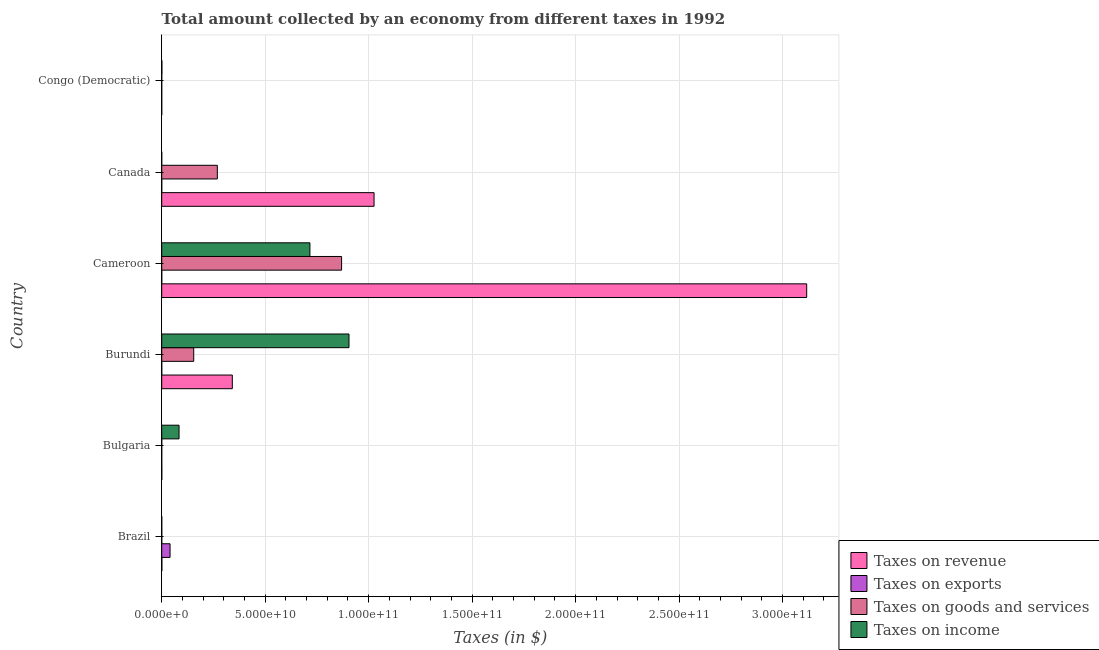Are the number of bars per tick equal to the number of legend labels?
Your answer should be very brief. Yes. Are the number of bars on each tick of the Y-axis equal?
Keep it short and to the point. Yes. How many bars are there on the 3rd tick from the bottom?
Keep it short and to the point. 4. What is the label of the 3rd group of bars from the top?
Your answer should be compact. Cameroon. In how many cases, is the number of bars for a given country not equal to the number of legend labels?
Make the answer very short. 0. What is the amount collected as tax on income in Congo (Democratic)?
Offer a very short reply. 8.40e+07. Across all countries, what is the maximum amount collected as tax on exports?
Ensure brevity in your answer.  4.03e+09. Across all countries, what is the minimum amount collected as tax on exports?
Give a very brief answer. 34.5. In which country was the amount collected as tax on goods maximum?
Offer a terse response. Cameroon. In which country was the amount collected as tax on exports minimum?
Your answer should be very brief. Bulgaria. What is the total amount collected as tax on income in the graph?
Your response must be concise. 1.71e+11. What is the difference between the amount collected as tax on revenue in Brazil and that in Congo (Democratic)?
Offer a very short reply. 6.24e+07. What is the difference between the amount collected as tax on goods in Burundi and the amount collected as tax on revenue in Brazil?
Your answer should be very brief. 1.54e+1. What is the average amount collected as tax on revenue per country?
Your response must be concise. 7.47e+1. What is the difference between the amount collected as tax on revenue and amount collected as tax on goods in Canada?
Make the answer very short. 7.57e+1. What is the difference between the highest and the second highest amount collected as tax on goods?
Provide a short and direct response. 6.00e+1. What is the difference between the highest and the lowest amount collected as tax on goods?
Provide a succinct answer. 8.69e+1. Is the sum of the amount collected as tax on revenue in Bulgaria and Congo (Democratic) greater than the maximum amount collected as tax on income across all countries?
Provide a succinct answer. No. What does the 2nd bar from the top in Canada represents?
Keep it short and to the point. Taxes on goods and services. What does the 2nd bar from the bottom in Congo (Democratic) represents?
Provide a short and direct response. Taxes on exports. How many bars are there?
Provide a short and direct response. 24. Are all the bars in the graph horizontal?
Ensure brevity in your answer.  Yes. What is the difference between two consecutive major ticks on the X-axis?
Provide a short and direct response. 5.00e+1. Are the values on the major ticks of X-axis written in scientific E-notation?
Make the answer very short. Yes. Does the graph contain grids?
Give a very brief answer. Yes. How many legend labels are there?
Provide a succinct answer. 4. How are the legend labels stacked?
Ensure brevity in your answer.  Vertical. What is the title of the graph?
Offer a very short reply. Total amount collected by an economy from different taxes in 1992. What is the label or title of the X-axis?
Keep it short and to the point. Taxes (in $). What is the Taxes (in $) in Taxes on revenue in Brazil?
Your answer should be very brief. 6.24e+07. What is the Taxes (in $) in Taxes on exports in Brazil?
Your answer should be compact. 4.03e+09. What is the Taxes (in $) of Taxes on goods and services in Brazil?
Give a very brief answer. 2.66e+07. What is the Taxes (in $) in Taxes on income in Brazil?
Your answer should be compact. 1.51e+07. What is the Taxes (in $) in Taxes on revenue in Bulgaria?
Provide a short and direct response. 3.39e+07. What is the Taxes (in $) of Taxes on exports in Bulgaria?
Your answer should be compact. 34.5. What is the Taxes (in $) in Taxes on goods and services in Bulgaria?
Ensure brevity in your answer.  1.02e+07. What is the Taxes (in $) in Taxes on income in Bulgaria?
Make the answer very short. 8.37e+09. What is the Taxes (in $) in Taxes on revenue in Burundi?
Provide a succinct answer. 3.41e+1. What is the Taxes (in $) of Taxes on goods and services in Burundi?
Provide a succinct answer. 1.55e+1. What is the Taxes (in $) in Taxes on income in Burundi?
Give a very brief answer. 9.05e+1. What is the Taxes (in $) of Taxes on revenue in Cameroon?
Keep it short and to the point. 3.12e+11. What is the Taxes (in $) of Taxes on exports in Cameroon?
Keep it short and to the point. 1.52e+07. What is the Taxes (in $) of Taxes on goods and services in Cameroon?
Provide a succinct answer. 8.69e+1. What is the Taxes (in $) of Taxes on income in Cameroon?
Make the answer very short. 7.16e+1. What is the Taxes (in $) in Taxes on revenue in Canada?
Offer a terse response. 1.03e+11. What is the Taxes (in $) of Taxes on exports in Canada?
Provide a succinct answer. 1.18e+07. What is the Taxes (in $) in Taxes on goods and services in Canada?
Make the answer very short. 2.69e+1. What is the Taxes (in $) in Taxes on income in Canada?
Your response must be concise. 104.33. What is the Taxes (in $) in Taxes on revenue in Congo (Democratic)?
Your answer should be very brief. 482.66. What is the Taxes (in $) in Taxes on exports in Congo (Democratic)?
Give a very brief answer. 3.20e+05. What is the Taxes (in $) in Taxes on goods and services in Congo (Democratic)?
Your answer should be compact. 188.26. What is the Taxes (in $) in Taxes on income in Congo (Democratic)?
Provide a short and direct response. 8.40e+07. Across all countries, what is the maximum Taxes (in $) in Taxes on revenue?
Offer a terse response. 3.12e+11. Across all countries, what is the maximum Taxes (in $) of Taxes on exports?
Provide a succinct answer. 4.03e+09. Across all countries, what is the maximum Taxes (in $) of Taxes on goods and services?
Give a very brief answer. 8.69e+1. Across all countries, what is the maximum Taxes (in $) of Taxes on income?
Provide a short and direct response. 9.05e+1. Across all countries, what is the minimum Taxes (in $) in Taxes on revenue?
Your answer should be very brief. 482.66. Across all countries, what is the minimum Taxes (in $) in Taxes on exports?
Offer a terse response. 34.5. Across all countries, what is the minimum Taxes (in $) of Taxes on goods and services?
Provide a short and direct response. 188.26. Across all countries, what is the minimum Taxes (in $) of Taxes on income?
Provide a succinct answer. 104.33. What is the total Taxes (in $) in Taxes on revenue in the graph?
Your response must be concise. 4.48e+11. What is the total Taxes (in $) of Taxes on exports in the graph?
Provide a succinct answer. 4.07e+09. What is the total Taxes (in $) in Taxes on goods and services in the graph?
Make the answer very short. 1.29e+11. What is the total Taxes (in $) of Taxes on income in the graph?
Ensure brevity in your answer.  1.71e+11. What is the difference between the Taxes (in $) of Taxes on revenue in Brazil and that in Bulgaria?
Your response must be concise. 2.84e+07. What is the difference between the Taxes (in $) of Taxes on exports in Brazil and that in Bulgaria?
Your response must be concise. 4.03e+09. What is the difference between the Taxes (in $) in Taxes on goods and services in Brazil and that in Bulgaria?
Make the answer very short. 1.63e+07. What is the difference between the Taxes (in $) of Taxes on income in Brazil and that in Bulgaria?
Keep it short and to the point. -8.36e+09. What is the difference between the Taxes (in $) in Taxes on revenue in Brazil and that in Burundi?
Make the answer very short. -3.41e+1. What is the difference between the Taxes (in $) in Taxes on exports in Brazil and that in Burundi?
Keep it short and to the point. 4.02e+09. What is the difference between the Taxes (in $) of Taxes on goods and services in Brazil and that in Burundi?
Ensure brevity in your answer.  -1.54e+1. What is the difference between the Taxes (in $) of Taxes on income in Brazil and that in Burundi?
Your answer should be very brief. -9.05e+1. What is the difference between the Taxes (in $) in Taxes on revenue in Brazil and that in Cameroon?
Your answer should be very brief. -3.12e+11. What is the difference between the Taxes (in $) in Taxes on exports in Brazil and that in Cameroon?
Provide a succinct answer. 4.01e+09. What is the difference between the Taxes (in $) of Taxes on goods and services in Brazil and that in Cameroon?
Ensure brevity in your answer.  -8.69e+1. What is the difference between the Taxes (in $) of Taxes on income in Brazil and that in Cameroon?
Your answer should be compact. -7.16e+1. What is the difference between the Taxes (in $) in Taxes on revenue in Brazil and that in Canada?
Give a very brief answer. -1.03e+11. What is the difference between the Taxes (in $) of Taxes on exports in Brazil and that in Canada?
Your response must be concise. 4.02e+09. What is the difference between the Taxes (in $) of Taxes on goods and services in Brazil and that in Canada?
Your response must be concise. -2.68e+1. What is the difference between the Taxes (in $) of Taxes on income in Brazil and that in Canada?
Give a very brief answer. 1.51e+07. What is the difference between the Taxes (in $) of Taxes on revenue in Brazil and that in Congo (Democratic)?
Provide a succinct answer. 6.24e+07. What is the difference between the Taxes (in $) of Taxes on exports in Brazil and that in Congo (Democratic)?
Provide a succinct answer. 4.03e+09. What is the difference between the Taxes (in $) in Taxes on goods and services in Brazil and that in Congo (Democratic)?
Give a very brief answer. 2.66e+07. What is the difference between the Taxes (in $) in Taxes on income in Brazil and that in Congo (Democratic)?
Make the answer very short. -6.89e+07. What is the difference between the Taxes (in $) in Taxes on revenue in Bulgaria and that in Burundi?
Make the answer very short. -3.41e+1. What is the difference between the Taxes (in $) of Taxes on exports in Bulgaria and that in Burundi?
Provide a succinct answer. -1.20e+07. What is the difference between the Taxes (in $) of Taxes on goods and services in Bulgaria and that in Burundi?
Provide a short and direct response. -1.55e+1. What is the difference between the Taxes (in $) of Taxes on income in Bulgaria and that in Burundi?
Provide a short and direct response. -8.21e+1. What is the difference between the Taxes (in $) of Taxes on revenue in Bulgaria and that in Cameroon?
Offer a very short reply. -3.12e+11. What is the difference between the Taxes (in $) of Taxes on exports in Bulgaria and that in Cameroon?
Ensure brevity in your answer.  -1.52e+07. What is the difference between the Taxes (in $) in Taxes on goods and services in Bulgaria and that in Cameroon?
Provide a succinct answer. -8.69e+1. What is the difference between the Taxes (in $) in Taxes on income in Bulgaria and that in Cameroon?
Ensure brevity in your answer.  -6.32e+1. What is the difference between the Taxes (in $) of Taxes on revenue in Bulgaria and that in Canada?
Offer a very short reply. -1.03e+11. What is the difference between the Taxes (in $) in Taxes on exports in Bulgaria and that in Canada?
Offer a terse response. -1.18e+07. What is the difference between the Taxes (in $) of Taxes on goods and services in Bulgaria and that in Canada?
Give a very brief answer. -2.69e+1. What is the difference between the Taxes (in $) of Taxes on income in Bulgaria and that in Canada?
Provide a short and direct response. 8.37e+09. What is the difference between the Taxes (in $) in Taxes on revenue in Bulgaria and that in Congo (Democratic)?
Offer a very short reply. 3.39e+07. What is the difference between the Taxes (in $) of Taxes on exports in Bulgaria and that in Congo (Democratic)?
Your answer should be compact. -3.20e+05. What is the difference between the Taxes (in $) in Taxes on goods and services in Bulgaria and that in Congo (Democratic)?
Your answer should be very brief. 1.02e+07. What is the difference between the Taxes (in $) of Taxes on income in Bulgaria and that in Congo (Democratic)?
Make the answer very short. 8.29e+09. What is the difference between the Taxes (in $) of Taxes on revenue in Burundi and that in Cameroon?
Offer a very short reply. -2.78e+11. What is the difference between the Taxes (in $) in Taxes on exports in Burundi and that in Cameroon?
Your response must be concise. -3.20e+06. What is the difference between the Taxes (in $) in Taxes on goods and services in Burundi and that in Cameroon?
Keep it short and to the point. -7.15e+1. What is the difference between the Taxes (in $) in Taxes on income in Burundi and that in Cameroon?
Provide a short and direct response. 1.89e+1. What is the difference between the Taxes (in $) of Taxes on revenue in Burundi and that in Canada?
Make the answer very short. -6.85e+1. What is the difference between the Taxes (in $) of Taxes on exports in Burundi and that in Canada?
Your answer should be very brief. 1.70e+05. What is the difference between the Taxes (in $) of Taxes on goods and services in Burundi and that in Canada?
Offer a very short reply. -1.14e+1. What is the difference between the Taxes (in $) of Taxes on income in Burundi and that in Canada?
Provide a short and direct response. 9.05e+1. What is the difference between the Taxes (in $) in Taxes on revenue in Burundi and that in Congo (Democratic)?
Offer a terse response. 3.41e+1. What is the difference between the Taxes (in $) of Taxes on exports in Burundi and that in Congo (Democratic)?
Your answer should be compact. 1.17e+07. What is the difference between the Taxes (in $) in Taxes on goods and services in Burundi and that in Congo (Democratic)?
Ensure brevity in your answer.  1.55e+1. What is the difference between the Taxes (in $) in Taxes on income in Burundi and that in Congo (Democratic)?
Your response must be concise. 9.04e+1. What is the difference between the Taxes (in $) in Taxes on revenue in Cameroon and that in Canada?
Your response must be concise. 2.09e+11. What is the difference between the Taxes (in $) of Taxes on exports in Cameroon and that in Canada?
Provide a short and direct response. 3.37e+06. What is the difference between the Taxes (in $) of Taxes on goods and services in Cameroon and that in Canada?
Offer a very short reply. 6.00e+1. What is the difference between the Taxes (in $) in Taxes on income in Cameroon and that in Canada?
Your response must be concise. 7.16e+1. What is the difference between the Taxes (in $) in Taxes on revenue in Cameroon and that in Congo (Democratic)?
Make the answer very short. 3.12e+11. What is the difference between the Taxes (in $) in Taxes on exports in Cameroon and that in Congo (Democratic)?
Provide a short and direct response. 1.49e+07. What is the difference between the Taxes (in $) of Taxes on goods and services in Cameroon and that in Congo (Democratic)?
Offer a terse response. 8.69e+1. What is the difference between the Taxes (in $) in Taxes on income in Cameroon and that in Congo (Democratic)?
Make the answer very short. 7.15e+1. What is the difference between the Taxes (in $) in Taxes on revenue in Canada and that in Congo (Democratic)?
Your answer should be very brief. 1.03e+11. What is the difference between the Taxes (in $) in Taxes on exports in Canada and that in Congo (Democratic)?
Ensure brevity in your answer.  1.15e+07. What is the difference between the Taxes (in $) in Taxes on goods and services in Canada and that in Congo (Democratic)?
Provide a succinct answer. 2.69e+1. What is the difference between the Taxes (in $) in Taxes on income in Canada and that in Congo (Democratic)?
Your answer should be compact. -8.40e+07. What is the difference between the Taxes (in $) of Taxes on revenue in Brazil and the Taxes (in $) of Taxes on exports in Bulgaria?
Offer a very short reply. 6.24e+07. What is the difference between the Taxes (in $) in Taxes on revenue in Brazil and the Taxes (in $) in Taxes on goods and services in Bulgaria?
Offer a very short reply. 5.21e+07. What is the difference between the Taxes (in $) in Taxes on revenue in Brazil and the Taxes (in $) in Taxes on income in Bulgaria?
Offer a very short reply. -8.31e+09. What is the difference between the Taxes (in $) in Taxes on exports in Brazil and the Taxes (in $) in Taxes on goods and services in Bulgaria?
Provide a succinct answer. 4.02e+09. What is the difference between the Taxes (in $) in Taxes on exports in Brazil and the Taxes (in $) in Taxes on income in Bulgaria?
Give a very brief answer. -4.34e+09. What is the difference between the Taxes (in $) in Taxes on goods and services in Brazil and the Taxes (in $) in Taxes on income in Bulgaria?
Offer a terse response. -8.35e+09. What is the difference between the Taxes (in $) in Taxes on revenue in Brazil and the Taxes (in $) in Taxes on exports in Burundi?
Your response must be concise. 5.04e+07. What is the difference between the Taxes (in $) of Taxes on revenue in Brazil and the Taxes (in $) of Taxes on goods and services in Burundi?
Ensure brevity in your answer.  -1.54e+1. What is the difference between the Taxes (in $) in Taxes on revenue in Brazil and the Taxes (in $) in Taxes on income in Burundi?
Keep it short and to the point. -9.04e+1. What is the difference between the Taxes (in $) of Taxes on exports in Brazil and the Taxes (in $) of Taxes on goods and services in Burundi?
Keep it short and to the point. -1.14e+1. What is the difference between the Taxes (in $) of Taxes on exports in Brazil and the Taxes (in $) of Taxes on income in Burundi?
Provide a short and direct response. -8.65e+1. What is the difference between the Taxes (in $) of Taxes on goods and services in Brazil and the Taxes (in $) of Taxes on income in Burundi?
Your response must be concise. -9.05e+1. What is the difference between the Taxes (in $) in Taxes on revenue in Brazil and the Taxes (in $) in Taxes on exports in Cameroon?
Ensure brevity in your answer.  4.72e+07. What is the difference between the Taxes (in $) in Taxes on revenue in Brazil and the Taxes (in $) in Taxes on goods and services in Cameroon?
Your answer should be compact. -8.69e+1. What is the difference between the Taxes (in $) of Taxes on revenue in Brazil and the Taxes (in $) of Taxes on income in Cameroon?
Provide a succinct answer. -7.16e+1. What is the difference between the Taxes (in $) in Taxes on exports in Brazil and the Taxes (in $) in Taxes on goods and services in Cameroon?
Provide a succinct answer. -8.29e+1. What is the difference between the Taxes (in $) in Taxes on exports in Brazil and the Taxes (in $) in Taxes on income in Cameroon?
Your answer should be compact. -6.76e+1. What is the difference between the Taxes (in $) in Taxes on goods and services in Brazil and the Taxes (in $) in Taxes on income in Cameroon?
Give a very brief answer. -7.16e+1. What is the difference between the Taxes (in $) in Taxes on revenue in Brazil and the Taxes (in $) in Taxes on exports in Canada?
Provide a short and direct response. 5.06e+07. What is the difference between the Taxes (in $) in Taxes on revenue in Brazil and the Taxes (in $) in Taxes on goods and services in Canada?
Give a very brief answer. -2.68e+1. What is the difference between the Taxes (in $) of Taxes on revenue in Brazil and the Taxes (in $) of Taxes on income in Canada?
Your response must be concise. 6.24e+07. What is the difference between the Taxes (in $) in Taxes on exports in Brazil and the Taxes (in $) in Taxes on goods and services in Canada?
Give a very brief answer. -2.28e+1. What is the difference between the Taxes (in $) of Taxes on exports in Brazil and the Taxes (in $) of Taxes on income in Canada?
Your answer should be very brief. 4.03e+09. What is the difference between the Taxes (in $) in Taxes on goods and services in Brazil and the Taxes (in $) in Taxes on income in Canada?
Offer a terse response. 2.66e+07. What is the difference between the Taxes (in $) in Taxes on revenue in Brazil and the Taxes (in $) in Taxes on exports in Congo (Democratic)?
Provide a short and direct response. 6.21e+07. What is the difference between the Taxes (in $) in Taxes on revenue in Brazil and the Taxes (in $) in Taxes on goods and services in Congo (Democratic)?
Provide a short and direct response. 6.24e+07. What is the difference between the Taxes (in $) of Taxes on revenue in Brazil and the Taxes (in $) of Taxes on income in Congo (Democratic)?
Offer a terse response. -2.16e+07. What is the difference between the Taxes (in $) in Taxes on exports in Brazil and the Taxes (in $) in Taxes on goods and services in Congo (Democratic)?
Your answer should be very brief. 4.03e+09. What is the difference between the Taxes (in $) of Taxes on exports in Brazil and the Taxes (in $) of Taxes on income in Congo (Democratic)?
Provide a short and direct response. 3.95e+09. What is the difference between the Taxes (in $) of Taxes on goods and services in Brazil and the Taxes (in $) of Taxes on income in Congo (Democratic)?
Your answer should be very brief. -5.74e+07. What is the difference between the Taxes (in $) in Taxes on revenue in Bulgaria and the Taxes (in $) in Taxes on exports in Burundi?
Keep it short and to the point. 2.19e+07. What is the difference between the Taxes (in $) in Taxes on revenue in Bulgaria and the Taxes (in $) in Taxes on goods and services in Burundi?
Keep it short and to the point. -1.54e+1. What is the difference between the Taxes (in $) in Taxes on revenue in Bulgaria and the Taxes (in $) in Taxes on income in Burundi?
Provide a succinct answer. -9.05e+1. What is the difference between the Taxes (in $) of Taxes on exports in Bulgaria and the Taxes (in $) of Taxes on goods and services in Burundi?
Provide a short and direct response. -1.55e+1. What is the difference between the Taxes (in $) of Taxes on exports in Bulgaria and the Taxes (in $) of Taxes on income in Burundi?
Your answer should be very brief. -9.05e+1. What is the difference between the Taxes (in $) of Taxes on goods and services in Bulgaria and the Taxes (in $) of Taxes on income in Burundi?
Provide a short and direct response. -9.05e+1. What is the difference between the Taxes (in $) in Taxes on revenue in Bulgaria and the Taxes (in $) in Taxes on exports in Cameroon?
Offer a terse response. 1.87e+07. What is the difference between the Taxes (in $) in Taxes on revenue in Bulgaria and the Taxes (in $) in Taxes on goods and services in Cameroon?
Provide a short and direct response. -8.69e+1. What is the difference between the Taxes (in $) in Taxes on revenue in Bulgaria and the Taxes (in $) in Taxes on income in Cameroon?
Offer a very short reply. -7.16e+1. What is the difference between the Taxes (in $) in Taxes on exports in Bulgaria and the Taxes (in $) in Taxes on goods and services in Cameroon?
Provide a succinct answer. -8.69e+1. What is the difference between the Taxes (in $) of Taxes on exports in Bulgaria and the Taxes (in $) of Taxes on income in Cameroon?
Provide a short and direct response. -7.16e+1. What is the difference between the Taxes (in $) in Taxes on goods and services in Bulgaria and the Taxes (in $) in Taxes on income in Cameroon?
Give a very brief answer. -7.16e+1. What is the difference between the Taxes (in $) of Taxes on revenue in Bulgaria and the Taxes (in $) of Taxes on exports in Canada?
Your response must be concise. 2.21e+07. What is the difference between the Taxes (in $) of Taxes on revenue in Bulgaria and the Taxes (in $) of Taxes on goods and services in Canada?
Provide a short and direct response. -2.68e+1. What is the difference between the Taxes (in $) in Taxes on revenue in Bulgaria and the Taxes (in $) in Taxes on income in Canada?
Provide a short and direct response. 3.39e+07. What is the difference between the Taxes (in $) in Taxes on exports in Bulgaria and the Taxes (in $) in Taxes on goods and services in Canada?
Make the answer very short. -2.69e+1. What is the difference between the Taxes (in $) in Taxes on exports in Bulgaria and the Taxes (in $) in Taxes on income in Canada?
Provide a succinct answer. -69.83. What is the difference between the Taxes (in $) in Taxes on goods and services in Bulgaria and the Taxes (in $) in Taxes on income in Canada?
Ensure brevity in your answer.  1.02e+07. What is the difference between the Taxes (in $) in Taxes on revenue in Bulgaria and the Taxes (in $) in Taxes on exports in Congo (Democratic)?
Keep it short and to the point. 3.36e+07. What is the difference between the Taxes (in $) in Taxes on revenue in Bulgaria and the Taxes (in $) in Taxes on goods and services in Congo (Democratic)?
Your response must be concise. 3.39e+07. What is the difference between the Taxes (in $) in Taxes on revenue in Bulgaria and the Taxes (in $) in Taxes on income in Congo (Democratic)?
Keep it short and to the point. -5.01e+07. What is the difference between the Taxes (in $) of Taxes on exports in Bulgaria and the Taxes (in $) of Taxes on goods and services in Congo (Democratic)?
Your answer should be compact. -153.76. What is the difference between the Taxes (in $) in Taxes on exports in Bulgaria and the Taxes (in $) in Taxes on income in Congo (Democratic)?
Keep it short and to the point. -8.40e+07. What is the difference between the Taxes (in $) of Taxes on goods and services in Bulgaria and the Taxes (in $) of Taxes on income in Congo (Democratic)?
Give a very brief answer. -7.38e+07. What is the difference between the Taxes (in $) in Taxes on revenue in Burundi and the Taxes (in $) in Taxes on exports in Cameroon?
Make the answer very short. 3.41e+1. What is the difference between the Taxes (in $) in Taxes on revenue in Burundi and the Taxes (in $) in Taxes on goods and services in Cameroon?
Keep it short and to the point. -5.28e+1. What is the difference between the Taxes (in $) in Taxes on revenue in Burundi and the Taxes (in $) in Taxes on income in Cameroon?
Make the answer very short. -3.75e+1. What is the difference between the Taxes (in $) of Taxes on exports in Burundi and the Taxes (in $) of Taxes on goods and services in Cameroon?
Offer a terse response. -8.69e+1. What is the difference between the Taxes (in $) of Taxes on exports in Burundi and the Taxes (in $) of Taxes on income in Cameroon?
Provide a succinct answer. -7.16e+1. What is the difference between the Taxes (in $) in Taxes on goods and services in Burundi and the Taxes (in $) in Taxes on income in Cameroon?
Ensure brevity in your answer.  -5.61e+1. What is the difference between the Taxes (in $) of Taxes on revenue in Burundi and the Taxes (in $) of Taxes on exports in Canada?
Give a very brief answer. 3.41e+1. What is the difference between the Taxes (in $) of Taxes on revenue in Burundi and the Taxes (in $) of Taxes on goods and services in Canada?
Ensure brevity in your answer.  7.24e+09. What is the difference between the Taxes (in $) in Taxes on revenue in Burundi and the Taxes (in $) in Taxes on income in Canada?
Offer a terse response. 3.41e+1. What is the difference between the Taxes (in $) of Taxes on exports in Burundi and the Taxes (in $) of Taxes on goods and services in Canada?
Offer a terse response. -2.69e+1. What is the difference between the Taxes (in $) of Taxes on exports in Burundi and the Taxes (in $) of Taxes on income in Canada?
Offer a terse response. 1.20e+07. What is the difference between the Taxes (in $) in Taxes on goods and services in Burundi and the Taxes (in $) in Taxes on income in Canada?
Ensure brevity in your answer.  1.55e+1. What is the difference between the Taxes (in $) in Taxes on revenue in Burundi and the Taxes (in $) in Taxes on exports in Congo (Democratic)?
Your answer should be very brief. 3.41e+1. What is the difference between the Taxes (in $) in Taxes on revenue in Burundi and the Taxes (in $) in Taxes on goods and services in Congo (Democratic)?
Make the answer very short. 3.41e+1. What is the difference between the Taxes (in $) in Taxes on revenue in Burundi and the Taxes (in $) in Taxes on income in Congo (Democratic)?
Your response must be concise. 3.40e+1. What is the difference between the Taxes (in $) in Taxes on exports in Burundi and the Taxes (in $) in Taxes on goods and services in Congo (Democratic)?
Provide a short and direct response. 1.20e+07. What is the difference between the Taxes (in $) of Taxes on exports in Burundi and the Taxes (in $) of Taxes on income in Congo (Democratic)?
Provide a succinct answer. -7.20e+07. What is the difference between the Taxes (in $) of Taxes on goods and services in Burundi and the Taxes (in $) of Taxes on income in Congo (Democratic)?
Keep it short and to the point. 1.54e+1. What is the difference between the Taxes (in $) of Taxes on revenue in Cameroon and the Taxes (in $) of Taxes on exports in Canada?
Your answer should be compact. 3.12e+11. What is the difference between the Taxes (in $) of Taxes on revenue in Cameroon and the Taxes (in $) of Taxes on goods and services in Canada?
Provide a succinct answer. 2.85e+11. What is the difference between the Taxes (in $) of Taxes on revenue in Cameroon and the Taxes (in $) of Taxes on income in Canada?
Make the answer very short. 3.12e+11. What is the difference between the Taxes (in $) of Taxes on exports in Cameroon and the Taxes (in $) of Taxes on goods and services in Canada?
Your answer should be very brief. -2.69e+1. What is the difference between the Taxes (in $) in Taxes on exports in Cameroon and the Taxes (in $) in Taxes on income in Canada?
Make the answer very short. 1.52e+07. What is the difference between the Taxes (in $) in Taxes on goods and services in Cameroon and the Taxes (in $) in Taxes on income in Canada?
Offer a terse response. 8.69e+1. What is the difference between the Taxes (in $) in Taxes on revenue in Cameroon and the Taxes (in $) in Taxes on exports in Congo (Democratic)?
Give a very brief answer. 3.12e+11. What is the difference between the Taxes (in $) in Taxes on revenue in Cameroon and the Taxes (in $) in Taxes on goods and services in Congo (Democratic)?
Provide a short and direct response. 3.12e+11. What is the difference between the Taxes (in $) of Taxes on revenue in Cameroon and the Taxes (in $) of Taxes on income in Congo (Democratic)?
Keep it short and to the point. 3.12e+11. What is the difference between the Taxes (in $) of Taxes on exports in Cameroon and the Taxes (in $) of Taxes on goods and services in Congo (Democratic)?
Your answer should be compact. 1.52e+07. What is the difference between the Taxes (in $) in Taxes on exports in Cameroon and the Taxes (in $) in Taxes on income in Congo (Democratic)?
Make the answer very short. -6.88e+07. What is the difference between the Taxes (in $) of Taxes on goods and services in Cameroon and the Taxes (in $) of Taxes on income in Congo (Democratic)?
Your answer should be very brief. 8.68e+1. What is the difference between the Taxes (in $) of Taxes on revenue in Canada and the Taxes (in $) of Taxes on exports in Congo (Democratic)?
Ensure brevity in your answer.  1.03e+11. What is the difference between the Taxes (in $) in Taxes on revenue in Canada and the Taxes (in $) in Taxes on goods and services in Congo (Democratic)?
Offer a very short reply. 1.03e+11. What is the difference between the Taxes (in $) in Taxes on revenue in Canada and the Taxes (in $) in Taxes on income in Congo (Democratic)?
Ensure brevity in your answer.  1.03e+11. What is the difference between the Taxes (in $) in Taxes on exports in Canada and the Taxes (in $) in Taxes on goods and services in Congo (Democratic)?
Keep it short and to the point. 1.18e+07. What is the difference between the Taxes (in $) in Taxes on exports in Canada and the Taxes (in $) in Taxes on income in Congo (Democratic)?
Give a very brief answer. -7.22e+07. What is the difference between the Taxes (in $) of Taxes on goods and services in Canada and the Taxes (in $) of Taxes on income in Congo (Democratic)?
Your response must be concise. 2.68e+1. What is the average Taxes (in $) of Taxes on revenue per country?
Keep it short and to the point. 7.47e+1. What is the average Taxes (in $) in Taxes on exports per country?
Offer a terse response. 6.78e+08. What is the average Taxes (in $) in Taxes on goods and services per country?
Your answer should be very brief. 2.15e+1. What is the average Taxes (in $) of Taxes on income per country?
Provide a short and direct response. 2.84e+1. What is the difference between the Taxes (in $) in Taxes on revenue and Taxes (in $) in Taxes on exports in Brazil?
Offer a terse response. -3.97e+09. What is the difference between the Taxes (in $) in Taxes on revenue and Taxes (in $) in Taxes on goods and services in Brazil?
Ensure brevity in your answer.  3.58e+07. What is the difference between the Taxes (in $) in Taxes on revenue and Taxes (in $) in Taxes on income in Brazil?
Make the answer very short. 4.73e+07. What is the difference between the Taxes (in $) in Taxes on exports and Taxes (in $) in Taxes on goods and services in Brazil?
Your response must be concise. 4.00e+09. What is the difference between the Taxes (in $) in Taxes on exports and Taxes (in $) in Taxes on income in Brazil?
Make the answer very short. 4.01e+09. What is the difference between the Taxes (in $) of Taxes on goods and services and Taxes (in $) of Taxes on income in Brazil?
Provide a succinct answer. 1.15e+07. What is the difference between the Taxes (in $) in Taxes on revenue and Taxes (in $) in Taxes on exports in Bulgaria?
Keep it short and to the point. 3.39e+07. What is the difference between the Taxes (in $) of Taxes on revenue and Taxes (in $) of Taxes on goods and services in Bulgaria?
Your response must be concise. 2.37e+07. What is the difference between the Taxes (in $) of Taxes on revenue and Taxes (in $) of Taxes on income in Bulgaria?
Ensure brevity in your answer.  -8.34e+09. What is the difference between the Taxes (in $) in Taxes on exports and Taxes (in $) in Taxes on goods and services in Bulgaria?
Offer a very short reply. -1.02e+07. What is the difference between the Taxes (in $) of Taxes on exports and Taxes (in $) of Taxes on income in Bulgaria?
Provide a short and direct response. -8.37e+09. What is the difference between the Taxes (in $) in Taxes on goods and services and Taxes (in $) in Taxes on income in Bulgaria?
Your answer should be very brief. -8.36e+09. What is the difference between the Taxes (in $) of Taxes on revenue and Taxes (in $) of Taxes on exports in Burundi?
Offer a terse response. 3.41e+1. What is the difference between the Taxes (in $) in Taxes on revenue and Taxes (in $) in Taxes on goods and services in Burundi?
Provide a short and direct response. 1.86e+1. What is the difference between the Taxes (in $) in Taxes on revenue and Taxes (in $) in Taxes on income in Burundi?
Your answer should be compact. -5.64e+1. What is the difference between the Taxes (in $) in Taxes on exports and Taxes (in $) in Taxes on goods and services in Burundi?
Give a very brief answer. -1.55e+1. What is the difference between the Taxes (in $) of Taxes on exports and Taxes (in $) of Taxes on income in Burundi?
Provide a succinct answer. -9.05e+1. What is the difference between the Taxes (in $) in Taxes on goods and services and Taxes (in $) in Taxes on income in Burundi?
Offer a terse response. -7.50e+1. What is the difference between the Taxes (in $) in Taxes on revenue and Taxes (in $) in Taxes on exports in Cameroon?
Your answer should be very brief. 3.12e+11. What is the difference between the Taxes (in $) in Taxes on revenue and Taxes (in $) in Taxes on goods and services in Cameroon?
Give a very brief answer. 2.25e+11. What is the difference between the Taxes (in $) in Taxes on revenue and Taxes (in $) in Taxes on income in Cameroon?
Provide a short and direct response. 2.40e+11. What is the difference between the Taxes (in $) of Taxes on exports and Taxes (in $) of Taxes on goods and services in Cameroon?
Provide a succinct answer. -8.69e+1. What is the difference between the Taxes (in $) in Taxes on exports and Taxes (in $) in Taxes on income in Cameroon?
Keep it short and to the point. -7.16e+1. What is the difference between the Taxes (in $) of Taxes on goods and services and Taxes (in $) of Taxes on income in Cameroon?
Provide a short and direct response. 1.53e+1. What is the difference between the Taxes (in $) in Taxes on revenue and Taxes (in $) in Taxes on exports in Canada?
Provide a succinct answer. 1.03e+11. What is the difference between the Taxes (in $) of Taxes on revenue and Taxes (in $) of Taxes on goods and services in Canada?
Provide a succinct answer. 7.57e+1. What is the difference between the Taxes (in $) in Taxes on revenue and Taxes (in $) in Taxes on income in Canada?
Provide a succinct answer. 1.03e+11. What is the difference between the Taxes (in $) in Taxes on exports and Taxes (in $) in Taxes on goods and services in Canada?
Your answer should be very brief. -2.69e+1. What is the difference between the Taxes (in $) in Taxes on exports and Taxes (in $) in Taxes on income in Canada?
Provide a succinct answer. 1.18e+07. What is the difference between the Taxes (in $) in Taxes on goods and services and Taxes (in $) in Taxes on income in Canada?
Offer a terse response. 2.69e+1. What is the difference between the Taxes (in $) in Taxes on revenue and Taxes (in $) in Taxes on exports in Congo (Democratic)?
Make the answer very short. -3.20e+05. What is the difference between the Taxes (in $) in Taxes on revenue and Taxes (in $) in Taxes on goods and services in Congo (Democratic)?
Your response must be concise. 294.4. What is the difference between the Taxes (in $) of Taxes on revenue and Taxes (in $) of Taxes on income in Congo (Democratic)?
Keep it short and to the point. -8.40e+07. What is the difference between the Taxes (in $) in Taxes on exports and Taxes (in $) in Taxes on goods and services in Congo (Democratic)?
Give a very brief answer. 3.20e+05. What is the difference between the Taxes (in $) in Taxes on exports and Taxes (in $) in Taxes on income in Congo (Democratic)?
Your answer should be very brief. -8.37e+07. What is the difference between the Taxes (in $) of Taxes on goods and services and Taxes (in $) of Taxes on income in Congo (Democratic)?
Provide a short and direct response. -8.40e+07. What is the ratio of the Taxes (in $) of Taxes on revenue in Brazil to that in Bulgaria?
Offer a terse response. 1.84. What is the ratio of the Taxes (in $) of Taxes on exports in Brazil to that in Bulgaria?
Your answer should be compact. 1.17e+08. What is the ratio of the Taxes (in $) of Taxes on goods and services in Brazil to that in Bulgaria?
Provide a succinct answer. 2.59. What is the ratio of the Taxes (in $) in Taxes on income in Brazil to that in Bulgaria?
Make the answer very short. 0. What is the ratio of the Taxes (in $) of Taxes on revenue in Brazil to that in Burundi?
Offer a terse response. 0. What is the ratio of the Taxes (in $) of Taxes on exports in Brazil to that in Burundi?
Your response must be concise. 335.83. What is the ratio of the Taxes (in $) in Taxes on goods and services in Brazil to that in Burundi?
Ensure brevity in your answer.  0. What is the ratio of the Taxes (in $) of Taxes on income in Brazil to that in Burundi?
Offer a very short reply. 0. What is the ratio of the Taxes (in $) in Taxes on exports in Brazil to that in Cameroon?
Provide a short and direct response. 265.13. What is the ratio of the Taxes (in $) of Taxes on goods and services in Brazil to that in Cameroon?
Ensure brevity in your answer.  0. What is the ratio of the Taxes (in $) in Taxes on income in Brazil to that in Cameroon?
Give a very brief answer. 0. What is the ratio of the Taxes (in $) in Taxes on revenue in Brazil to that in Canada?
Keep it short and to the point. 0. What is the ratio of the Taxes (in $) in Taxes on exports in Brazil to that in Canada?
Make the answer very short. 340.66. What is the ratio of the Taxes (in $) of Taxes on income in Brazil to that in Canada?
Make the answer very short. 1.45e+05. What is the ratio of the Taxes (in $) of Taxes on revenue in Brazil to that in Congo (Democratic)?
Your response must be concise. 1.29e+05. What is the ratio of the Taxes (in $) in Taxes on exports in Brazil to that in Congo (Democratic)?
Offer a very short reply. 1.26e+04. What is the ratio of the Taxes (in $) of Taxes on goods and services in Brazil to that in Congo (Democratic)?
Provide a succinct answer. 1.41e+05. What is the ratio of the Taxes (in $) of Taxes on income in Brazil to that in Congo (Democratic)?
Give a very brief answer. 0.18. What is the ratio of the Taxes (in $) of Taxes on exports in Bulgaria to that in Burundi?
Make the answer very short. 0. What is the ratio of the Taxes (in $) in Taxes on goods and services in Bulgaria to that in Burundi?
Your answer should be compact. 0. What is the ratio of the Taxes (in $) in Taxes on income in Bulgaria to that in Burundi?
Provide a succinct answer. 0.09. What is the ratio of the Taxes (in $) in Taxes on revenue in Bulgaria to that in Cameroon?
Keep it short and to the point. 0. What is the ratio of the Taxes (in $) in Taxes on goods and services in Bulgaria to that in Cameroon?
Offer a terse response. 0. What is the ratio of the Taxes (in $) of Taxes on income in Bulgaria to that in Cameroon?
Your answer should be compact. 0.12. What is the ratio of the Taxes (in $) of Taxes on revenue in Bulgaria to that in Canada?
Offer a very short reply. 0. What is the ratio of the Taxes (in $) of Taxes on goods and services in Bulgaria to that in Canada?
Your answer should be very brief. 0. What is the ratio of the Taxes (in $) in Taxes on income in Bulgaria to that in Canada?
Provide a succinct answer. 8.03e+07. What is the ratio of the Taxes (in $) in Taxes on revenue in Bulgaria to that in Congo (Democratic)?
Ensure brevity in your answer.  7.03e+04. What is the ratio of the Taxes (in $) in Taxes on exports in Bulgaria to that in Congo (Democratic)?
Keep it short and to the point. 0. What is the ratio of the Taxes (in $) in Taxes on goods and services in Bulgaria to that in Congo (Democratic)?
Offer a very short reply. 5.44e+04. What is the ratio of the Taxes (in $) in Taxes on income in Bulgaria to that in Congo (Democratic)?
Keep it short and to the point. 99.69. What is the ratio of the Taxes (in $) in Taxes on revenue in Burundi to that in Cameroon?
Make the answer very short. 0.11. What is the ratio of the Taxes (in $) of Taxes on exports in Burundi to that in Cameroon?
Your answer should be compact. 0.79. What is the ratio of the Taxes (in $) in Taxes on goods and services in Burundi to that in Cameroon?
Your answer should be very brief. 0.18. What is the ratio of the Taxes (in $) in Taxes on income in Burundi to that in Cameroon?
Keep it short and to the point. 1.26. What is the ratio of the Taxes (in $) of Taxes on revenue in Burundi to that in Canada?
Make the answer very short. 0.33. What is the ratio of the Taxes (in $) in Taxes on exports in Burundi to that in Canada?
Ensure brevity in your answer.  1.01. What is the ratio of the Taxes (in $) in Taxes on goods and services in Burundi to that in Canada?
Your answer should be very brief. 0.58. What is the ratio of the Taxes (in $) of Taxes on income in Burundi to that in Canada?
Your response must be concise. 8.67e+08. What is the ratio of the Taxes (in $) of Taxes on revenue in Burundi to that in Congo (Democratic)?
Provide a short and direct response. 7.07e+07. What is the ratio of the Taxes (in $) in Taxes on exports in Burundi to that in Congo (Democratic)?
Ensure brevity in your answer.  37.5. What is the ratio of the Taxes (in $) of Taxes on goods and services in Burundi to that in Congo (Democratic)?
Give a very brief answer. 8.22e+07. What is the ratio of the Taxes (in $) in Taxes on income in Burundi to that in Congo (Democratic)?
Offer a very short reply. 1077.38. What is the ratio of the Taxes (in $) of Taxes on revenue in Cameroon to that in Canada?
Ensure brevity in your answer.  3.04. What is the ratio of the Taxes (in $) in Taxes on exports in Cameroon to that in Canada?
Provide a short and direct response. 1.28. What is the ratio of the Taxes (in $) in Taxes on goods and services in Cameroon to that in Canada?
Provide a succinct answer. 3.23. What is the ratio of the Taxes (in $) of Taxes on income in Cameroon to that in Canada?
Your answer should be very brief. 6.86e+08. What is the ratio of the Taxes (in $) in Taxes on revenue in Cameroon to that in Congo (Democratic)?
Make the answer very short. 6.46e+08. What is the ratio of the Taxes (in $) in Taxes on exports in Cameroon to that in Congo (Democratic)?
Give a very brief answer. 47.5. What is the ratio of the Taxes (in $) in Taxes on goods and services in Cameroon to that in Congo (Democratic)?
Provide a succinct answer. 4.62e+08. What is the ratio of the Taxes (in $) of Taxes on income in Cameroon to that in Congo (Democratic)?
Keep it short and to the point. 852.56. What is the ratio of the Taxes (in $) in Taxes on revenue in Canada to that in Congo (Democratic)?
Offer a terse response. 2.13e+08. What is the ratio of the Taxes (in $) of Taxes on exports in Canada to that in Congo (Democratic)?
Provide a short and direct response. 36.97. What is the ratio of the Taxes (in $) of Taxes on goods and services in Canada to that in Congo (Democratic)?
Offer a terse response. 1.43e+08. What is the ratio of the Taxes (in $) in Taxes on income in Canada to that in Congo (Democratic)?
Provide a succinct answer. 0. What is the difference between the highest and the second highest Taxes (in $) in Taxes on revenue?
Your answer should be very brief. 2.09e+11. What is the difference between the highest and the second highest Taxes (in $) in Taxes on exports?
Provide a succinct answer. 4.01e+09. What is the difference between the highest and the second highest Taxes (in $) of Taxes on goods and services?
Keep it short and to the point. 6.00e+1. What is the difference between the highest and the second highest Taxes (in $) in Taxes on income?
Make the answer very short. 1.89e+1. What is the difference between the highest and the lowest Taxes (in $) in Taxes on revenue?
Your answer should be very brief. 3.12e+11. What is the difference between the highest and the lowest Taxes (in $) in Taxes on exports?
Make the answer very short. 4.03e+09. What is the difference between the highest and the lowest Taxes (in $) in Taxes on goods and services?
Your response must be concise. 8.69e+1. What is the difference between the highest and the lowest Taxes (in $) of Taxes on income?
Your answer should be compact. 9.05e+1. 